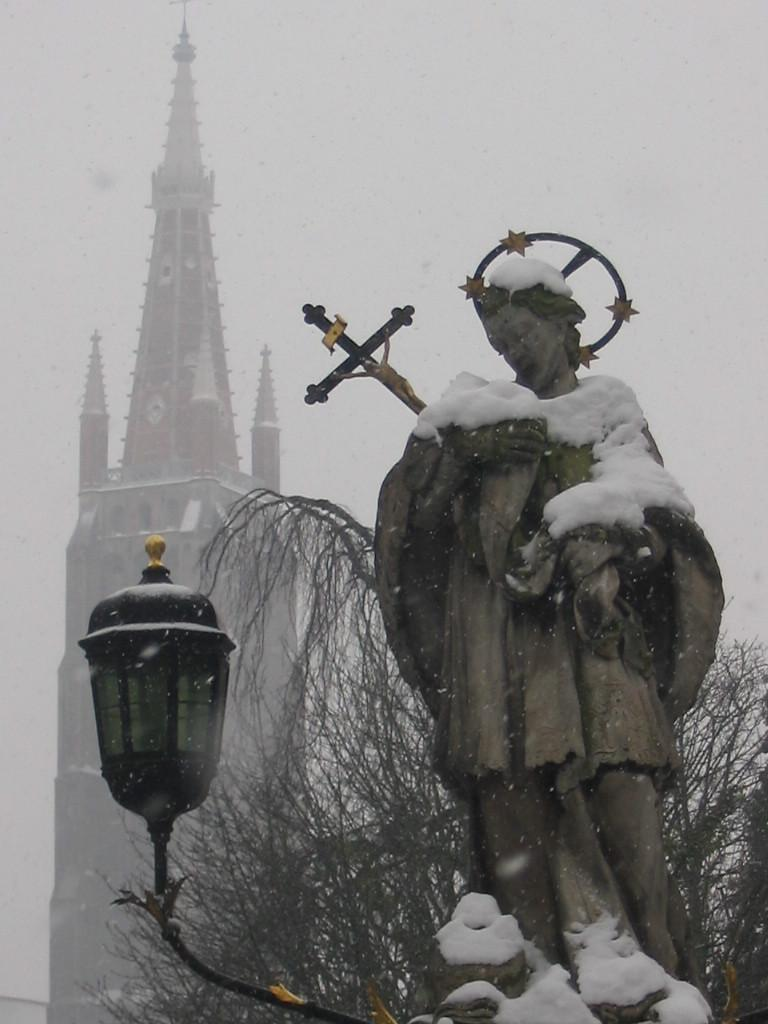What is the main subject in the image? There is a statue in the image. What is the weather like in the image? There is snow visible in the image. What can be seen in the background of the image? There is a building in the background of the image. What account does the statue have on a social media platform in the image? There is no information about the statue having an account on a social media platform in the image. What knowledge does the statue possess about quantum physics in the image? The statue is an inanimate object and cannot possess knowledge about any subject, including quantum physics. 